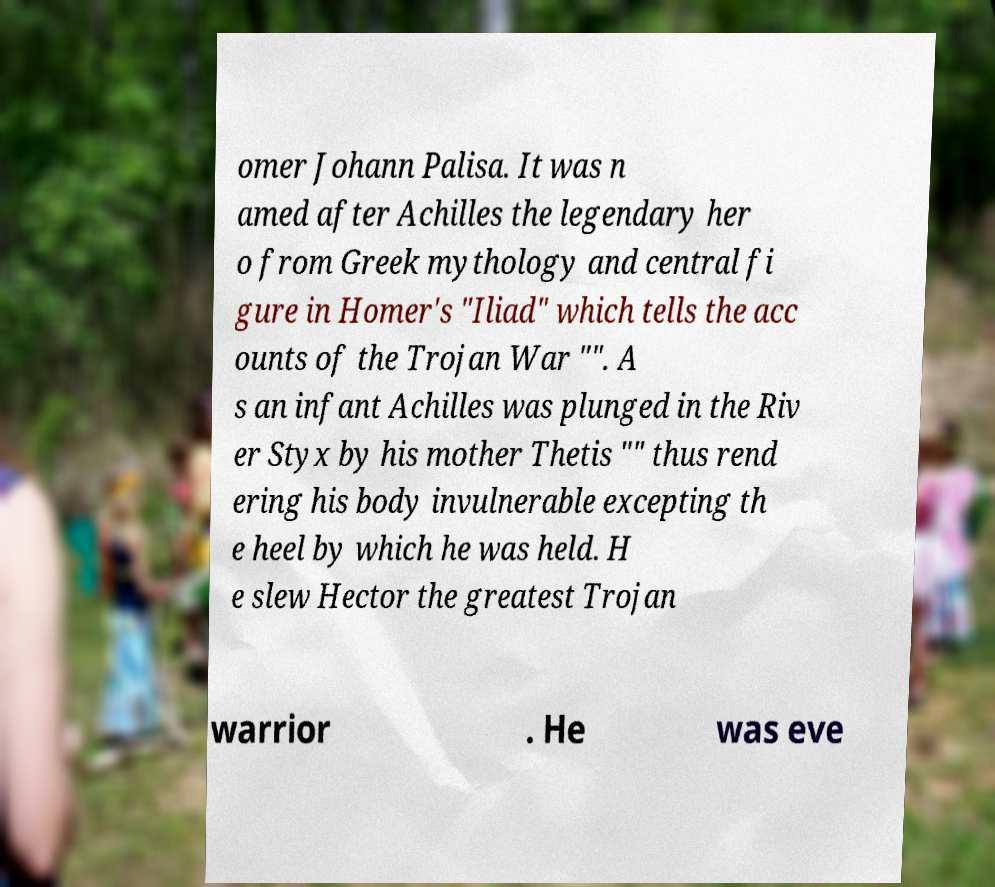For documentation purposes, I need the text within this image transcribed. Could you provide that? omer Johann Palisa. It was n amed after Achilles the legendary her o from Greek mythology and central fi gure in Homer's "Iliad" which tells the acc ounts of the Trojan War "". A s an infant Achilles was plunged in the Riv er Styx by his mother Thetis "" thus rend ering his body invulnerable excepting th e heel by which he was held. H e slew Hector the greatest Trojan warrior . He was eve 